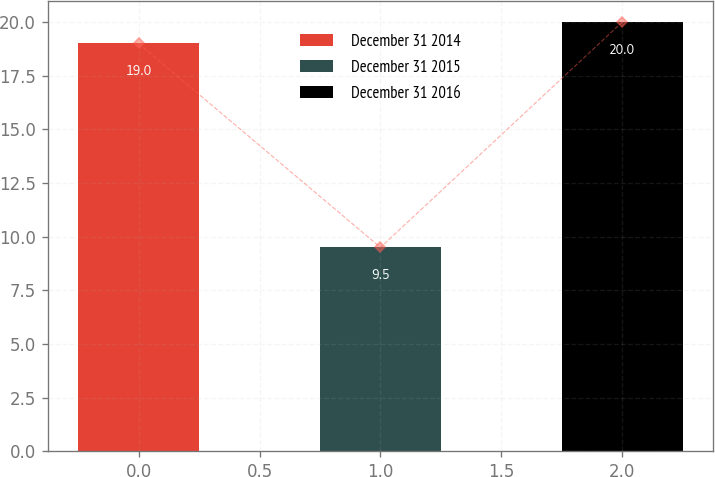Convert chart to OTSL. <chart><loc_0><loc_0><loc_500><loc_500><bar_chart><fcel>December 31 2014<fcel>December 31 2015<fcel>December 31 2016<nl><fcel>19<fcel>9.5<fcel>20<nl></chart> 